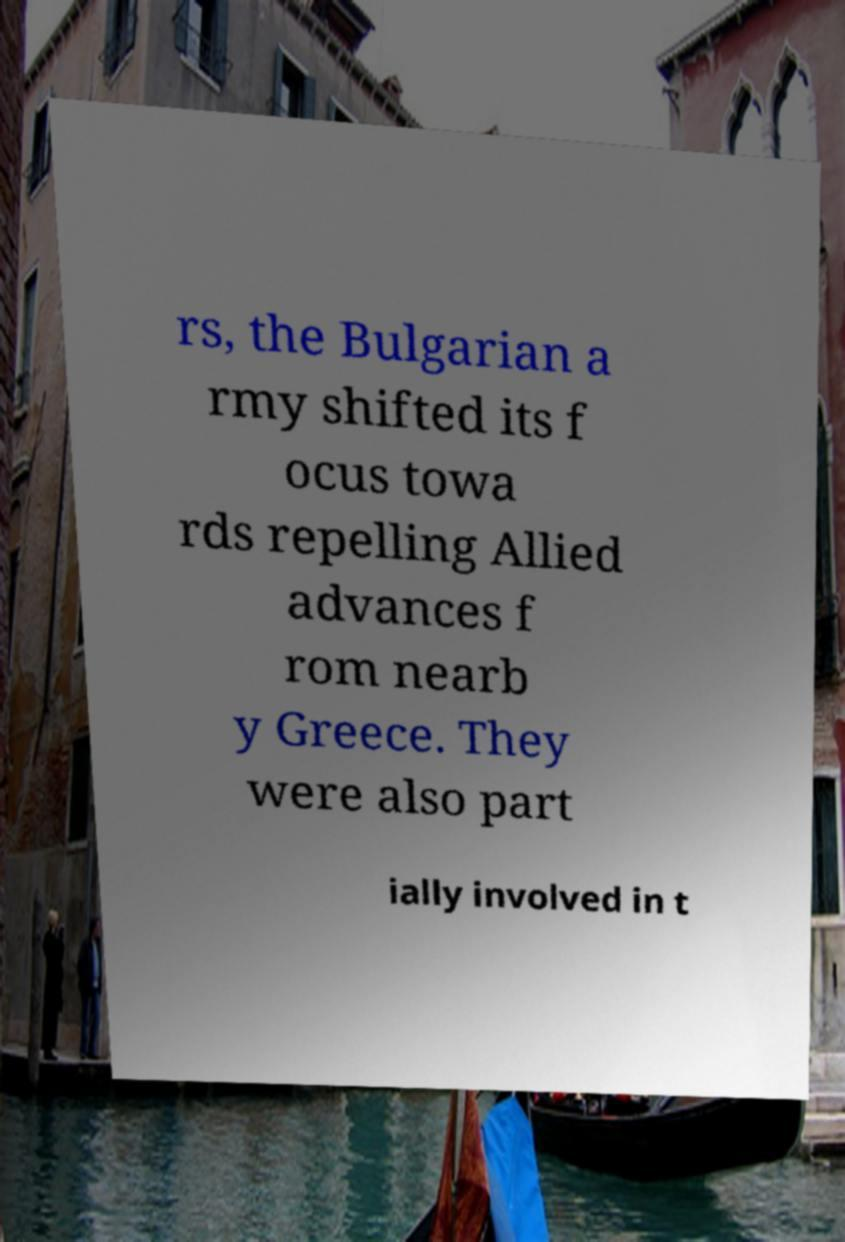Can you read and provide the text displayed in the image?This photo seems to have some interesting text. Can you extract and type it out for me? rs, the Bulgarian a rmy shifted its f ocus towa rds repelling Allied advances f rom nearb y Greece. They were also part ially involved in t 